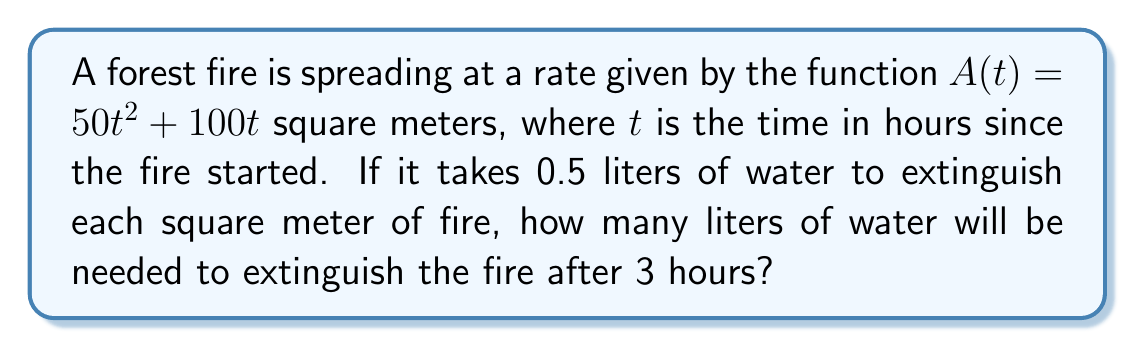Teach me how to tackle this problem. To solve this problem, we need to follow these steps:

1) First, we need to find the area of the fire after 3 hours. We can do this by plugging $t = 3$ into the given function:

   $A(3) = 50(3)^2 + 100(3) = 450 + 300 = 750$ square meters

2) Now that we know the area of the fire, we need to calculate how much water is needed to extinguish it. We're given that it takes 0.5 liters of water per square meter.

3) To find the total volume of water needed, we multiply the area by the water needed per square meter:

   $V = 750 \times 0.5 = 375$ liters

Therefore, 375 liters of water will be needed to extinguish the fire after 3 hours.

Note: This problem incorporates calculus concepts (rate of change, area functions) while relating to the firefighting background of the persona. The outdoor activity aspect could be integrated by imagining plotting the fire's growth on a large outdoor graph or using physical objects to represent the spreading fire.
Answer: 375 liters 